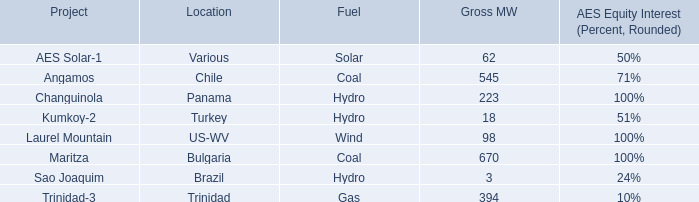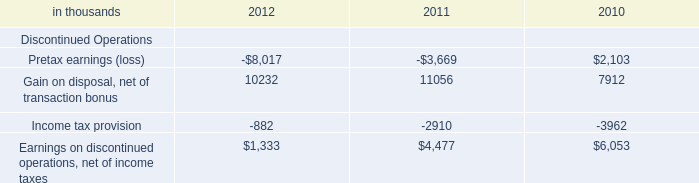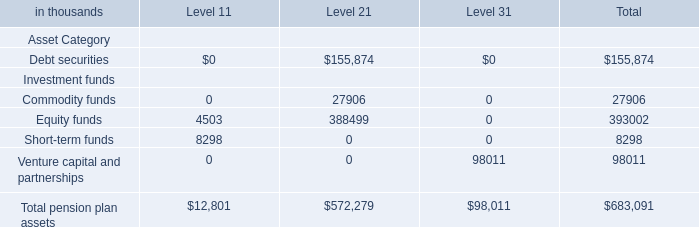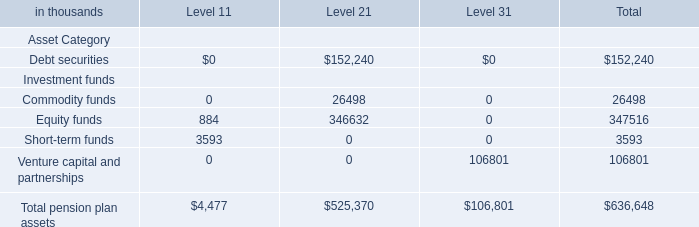what's the total amount of Gain on disposal, net of transaction bonus of 2011, and Commodity funds Investment funds of Level 2 ? 
Computations: (11056.0 + 26498.0)
Answer: 37554.0. 